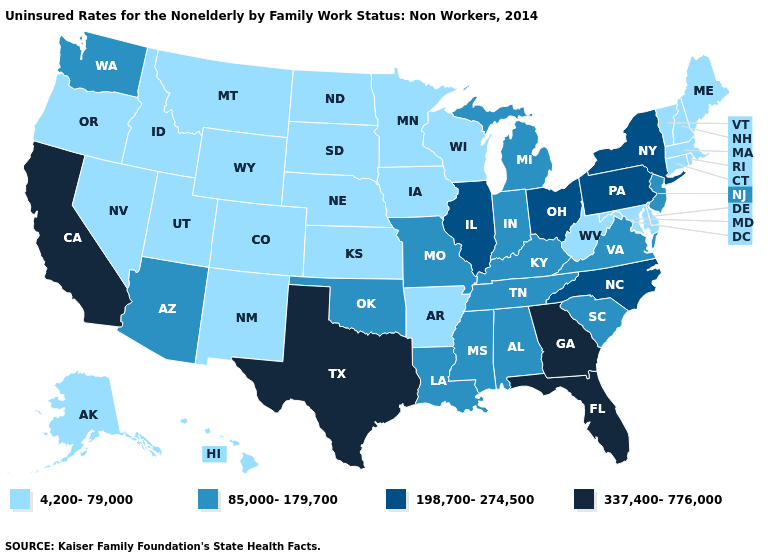How many symbols are there in the legend?
Quick response, please. 4. Does Nebraska have the lowest value in the USA?
Concise answer only. Yes. What is the value of Virginia?
Give a very brief answer. 85,000-179,700. How many symbols are there in the legend?
Answer briefly. 4. Does Alaska have the same value as Nevada?
Keep it brief. Yes. Name the states that have a value in the range 198,700-274,500?
Quick response, please. Illinois, New York, North Carolina, Ohio, Pennsylvania. Does Maine have a higher value than South Carolina?
Quick response, please. No. Name the states that have a value in the range 4,200-79,000?
Short answer required. Alaska, Arkansas, Colorado, Connecticut, Delaware, Hawaii, Idaho, Iowa, Kansas, Maine, Maryland, Massachusetts, Minnesota, Montana, Nebraska, Nevada, New Hampshire, New Mexico, North Dakota, Oregon, Rhode Island, South Dakota, Utah, Vermont, West Virginia, Wisconsin, Wyoming. What is the lowest value in states that border Minnesota?
Keep it brief. 4,200-79,000. Among the states that border North Dakota , which have the highest value?
Quick response, please. Minnesota, Montana, South Dakota. What is the value of West Virginia?
Answer briefly. 4,200-79,000. Name the states that have a value in the range 337,400-776,000?
Give a very brief answer. California, Florida, Georgia, Texas. Which states have the lowest value in the MidWest?
Quick response, please. Iowa, Kansas, Minnesota, Nebraska, North Dakota, South Dakota, Wisconsin. What is the lowest value in the USA?
Give a very brief answer. 4,200-79,000. 